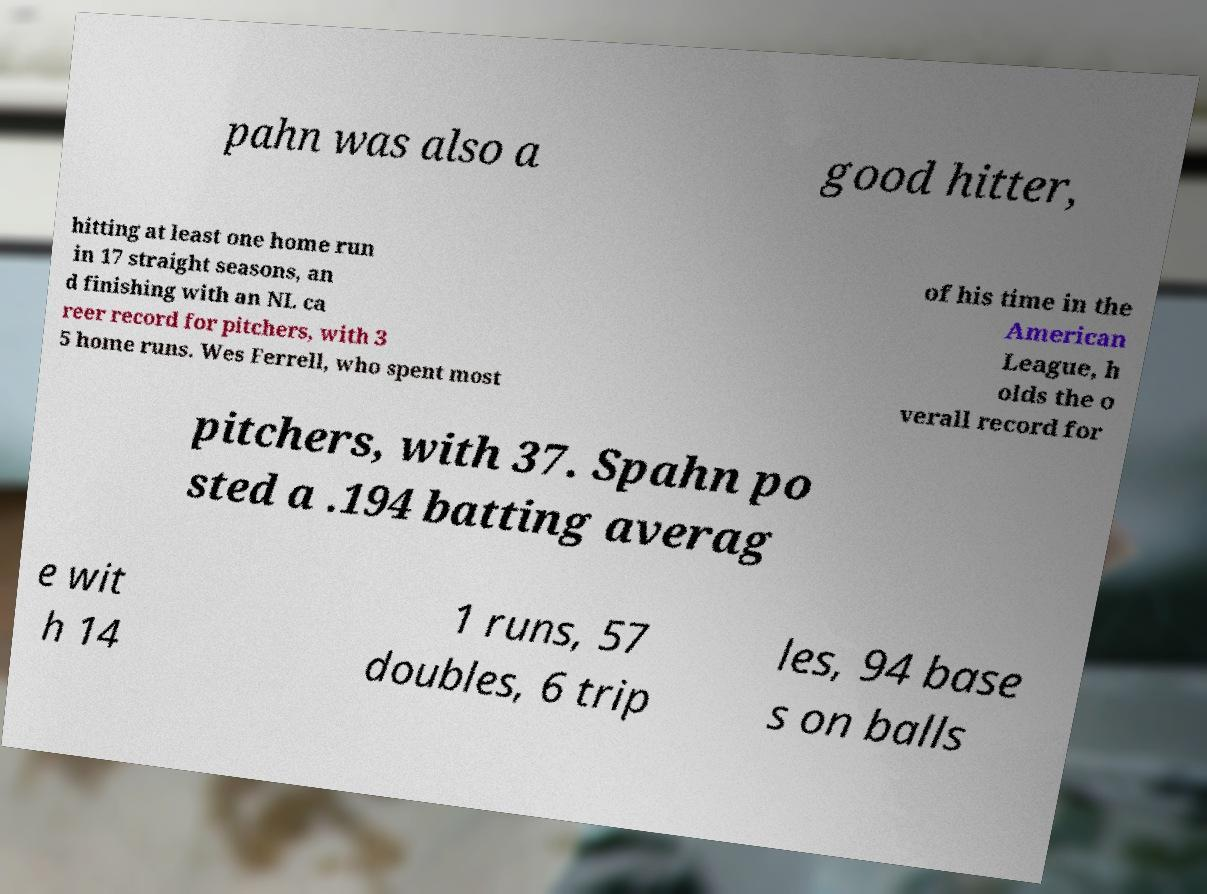What messages or text are displayed in this image? I need them in a readable, typed format. pahn was also a good hitter, hitting at least one home run in 17 straight seasons, an d finishing with an NL ca reer record for pitchers, with 3 5 home runs. Wes Ferrell, who spent most of his time in the American League, h olds the o verall record for pitchers, with 37. Spahn po sted a .194 batting averag e wit h 14 1 runs, 57 doubles, 6 trip les, 94 base s on balls 